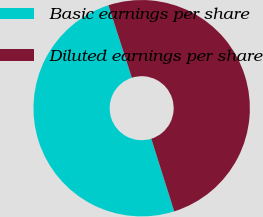<chart> <loc_0><loc_0><loc_500><loc_500><pie_chart><fcel>Basic earnings per share<fcel>Diluted earnings per share<nl><fcel>49.9%<fcel>50.1%<nl></chart> 